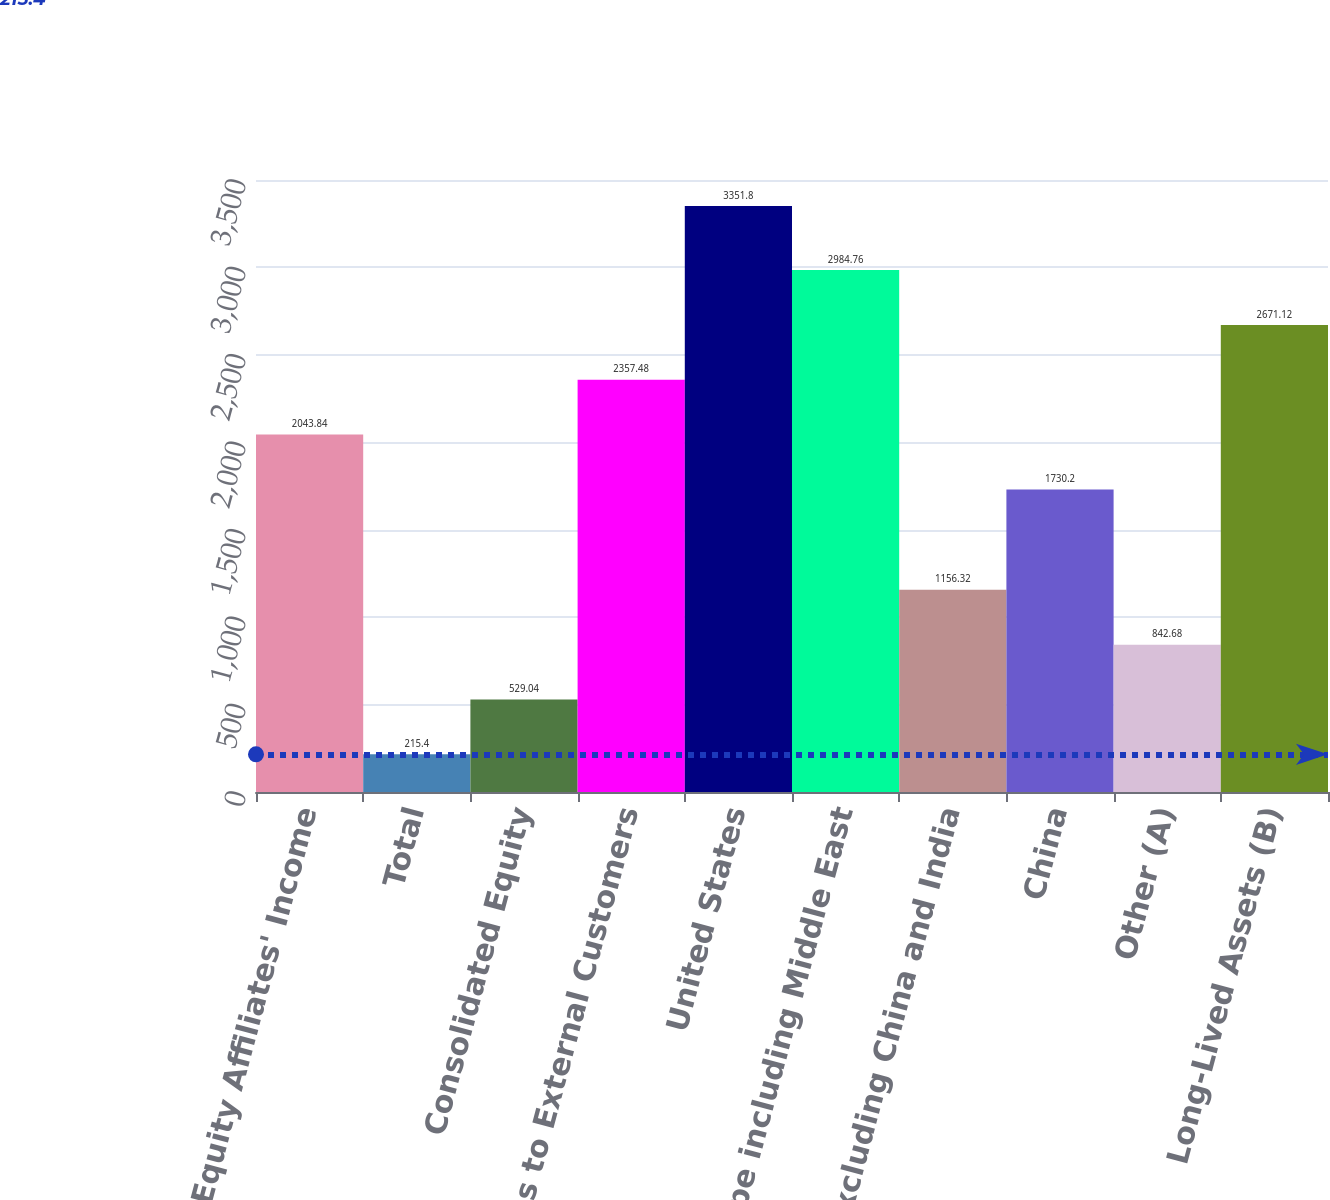Convert chart. <chart><loc_0><loc_0><loc_500><loc_500><bar_chart><fcel>Equity Affiliates' Income<fcel>Total<fcel>Consolidated Equity<fcel>Sales to External Customers<fcel>United States<fcel>Europe including Middle East<fcel>Asia excluding China and India<fcel>China<fcel>Other (A)<fcel>Long-Lived Assets (B)<nl><fcel>2043.84<fcel>215.4<fcel>529.04<fcel>2357.48<fcel>3351.8<fcel>2984.76<fcel>1156.32<fcel>1730.2<fcel>842.68<fcel>2671.12<nl></chart> 